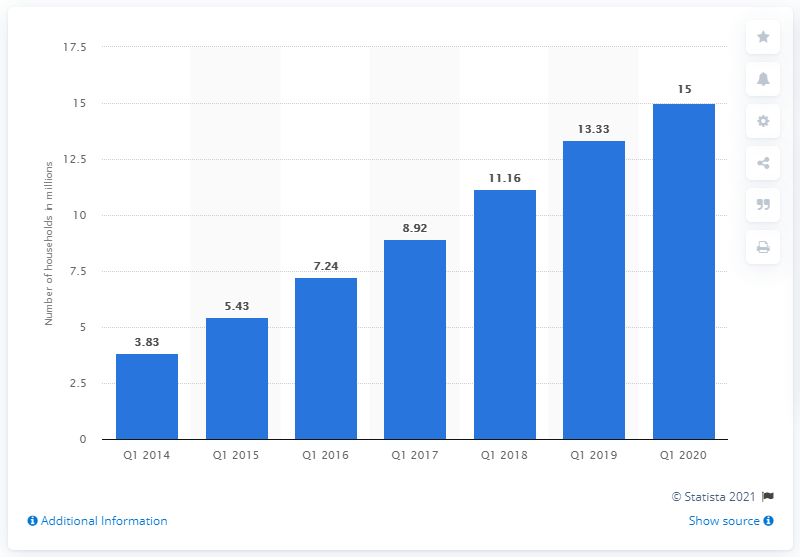Point out several critical features in this image. In the first quarter of 2020, a total of 15 households subscribed to the service. In the first quarter of 2014, there were 3.83 households that subscribed to an SVOD service. 